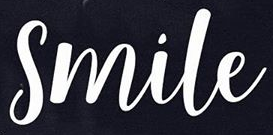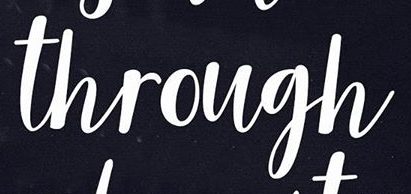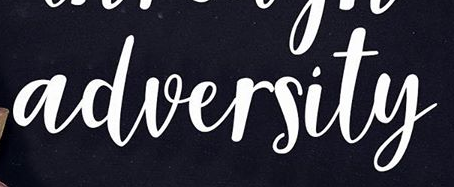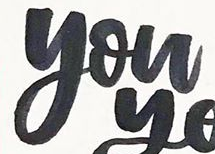What text appears in these images from left to right, separated by a semicolon? Smile; through; adversity; you 